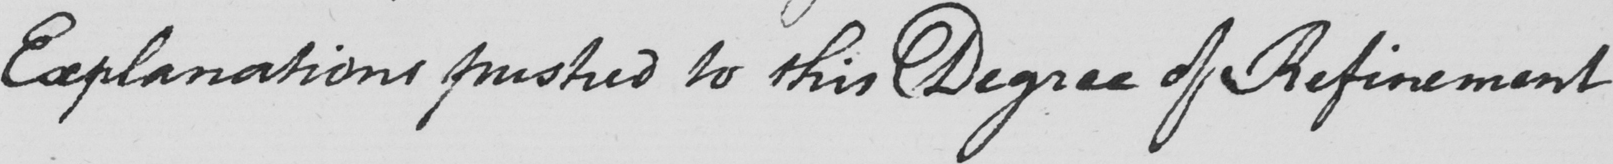What does this handwritten line say? Explanations pushed to this Degree of Refinement 